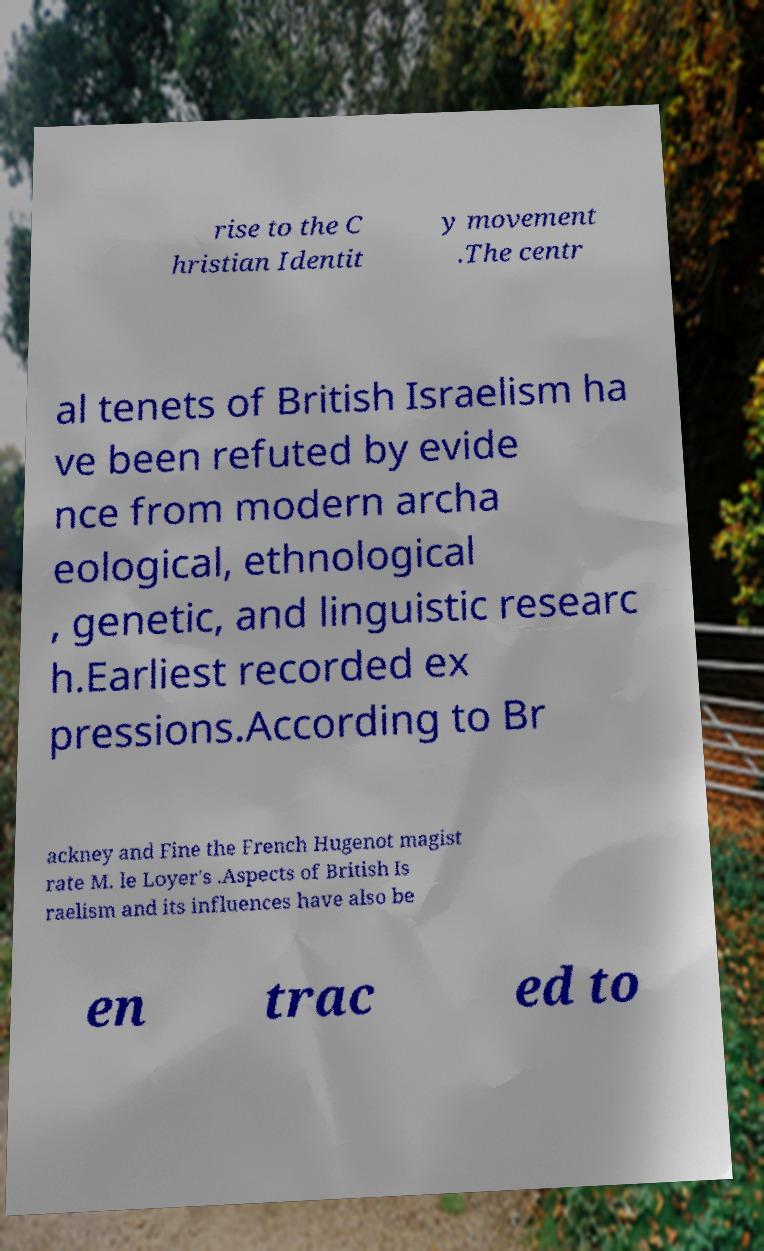For documentation purposes, I need the text within this image transcribed. Could you provide that? rise to the C hristian Identit y movement .The centr al tenets of British Israelism ha ve been refuted by evide nce from modern archa eological, ethnological , genetic, and linguistic researc h.Earliest recorded ex pressions.According to Br ackney and Fine the French Hugenot magist rate M. le Loyer's .Aspects of British Is raelism and its influences have also be en trac ed to 